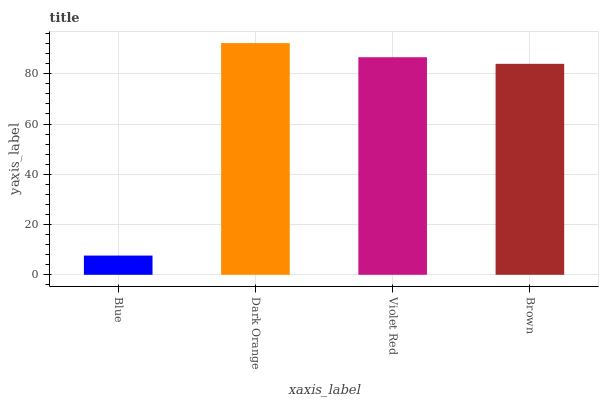Is Blue the minimum?
Answer yes or no. Yes. Is Dark Orange the maximum?
Answer yes or no. Yes. Is Violet Red the minimum?
Answer yes or no. No. Is Violet Red the maximum?
Answer yes or no. No. Is Dark Orange greater than Violet Red?
Answer yes or no. Yes. Is Violet Red less than Dark Orange?
Answer yes or no. Yes. Is Violet Red greater than Dark Orange?
Answer yes or no. No. Is Dark Orange less than Violet Red?
Answer yes or no. No. Is Violet Red the high median?
Answer yes or no. Yes. Is Brown the low median?
Answer yes or no. Yes. Is Brown the high median?
Answer yes or no. No. Is Dark Orange the low median?
Answer yes or no. No. 